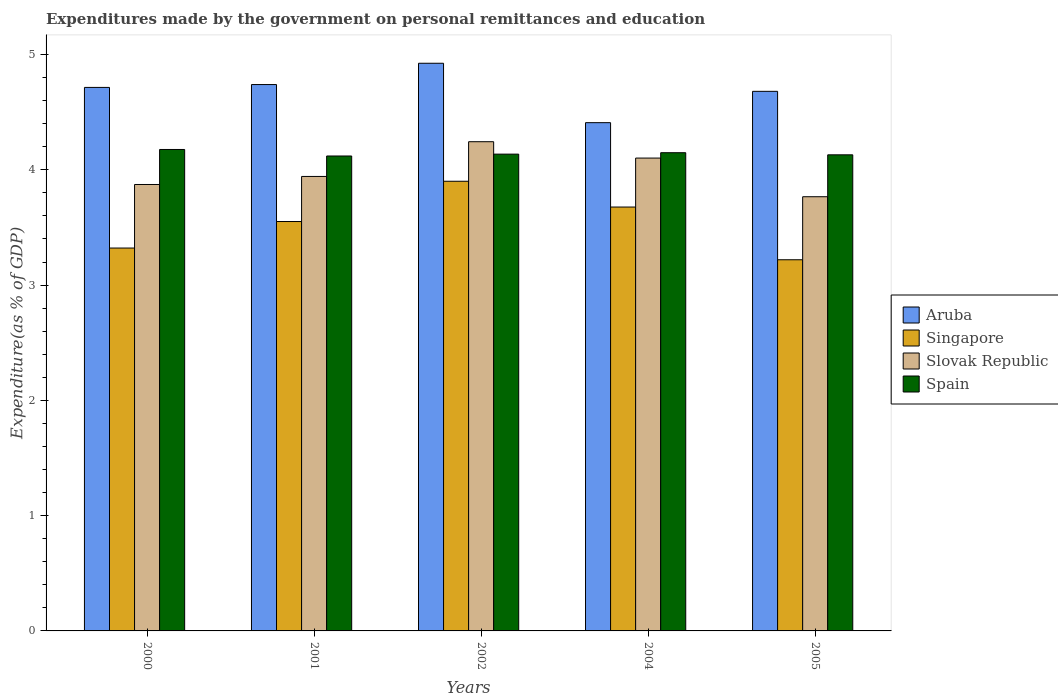Are the number of bars per tick equal to the number of legend labels?
Your answer should be compact. Yes. How many bars are there on the 3rd tick from the right?
Offer a terse response. 4. What is the expenditures made by the government on personal remittances and education in Singapore in 2001?
Make the answer very short. 3.55. Across all years, what is the maximum expenditures made by the government on personal remittances and education in Slovak Republic?
Make the answer very short. 4.24. Across all years, what is the minimum expenditures made by the government on personal remittances and education in Spain?
Keep it short and to the point. 4.12. In which year was the expenditures made by the government on personal remittances and education in Spain maximum?
Your response must be concise. 2000. What is the total expenditures made by the government on personal remittances and education in Singapore in the graph?
Offer a terse response. 17.67. What is the difference between the expenditures made by the government on personal remittances and education in Slovak Republic in 2000 and that in 2001?
Keep it short and to the point. -0.07. What is the difference between the expenditures made by the government on personal remittances and education in Aruba in 2005 and the expenditures made by the government on personal remittances and education in Slovak Republic in 2002?
Offer a terse response. 0.44. What is the average expenditures made by the government on personal remittances and education in Aruba per year?
Give a very brief answer. 4.69. In the year 2001, what is the difference between the expenditures made by the government on personal remittances and education in Slovak Republic and expenditures made by the government on personal remittances and education in Singapore?
Offer a terse response. 0.39. In how many years, is the expenditures made by the government on personal remittances and education in Singapore greater than 4.6 %?
Your response must be concise. 0. What is the ratio of the expenditures made by the government on personal remittances and education in Spain in 2000 to that in 2002?
Ensure brevity in your answer.  1.01. What is the difference between the highest and the second highest expenditures made by the government on personal remittances and education in Spain?
Your answer should be very brief. 0.03. What is the difference between the highest and the lowest expenditures made by the government on personal remittances and education in Spain?
Provide a succinct answer. 0.06. Is the sum of the expenditures made by the government on personal remittances and education in Spain in 2004 and 2005 greater than the maximum expenditures made by the government on personal remittances and education in Singapore across all years?
Ensure brevity in your answer.  Yes. What does the 1st bar from the left in 2001 represents?
Give a very brief answer. Aruba. What does the 3rd bar from the right in 2004 represents?
Offer a terse response. Singapore. Is it the case that in every year, the sum of the expenditures made by the government on personal remittances and education in Singapore and expenditures made by the government on personal remittances and education in Aruba is greater than the expenditures made by the government on personal remittances and education in Slovak Republic?
Your answer should be very brief. Yes. How many bars are there?
Your answer should be very brief. 20. Are the values on the major ticks of Y-axis written in scientific E-notation?
Ensure brevity in your answer.  No. Where does the legend appear in the graph?
Provide a short and direct response. Center right. What is the title of the graph?
Keep it short and to the point. Expenditures made by the government on personal remittances and education. What is the label or title of the Y-axis?
Your response must be concise. Expenditure(as % of GDP). What is the Expenditure(as % of GDP) of Aruba in 2000?
Ensure brevity in your answer.  4.71. What is the Expenditure(as % of GDP) in Singapore in 2000?
Make the answer very short. 3.32. What is the Expenditure(as % of GDP) in Slovak Republic in 2000?
Your response must be concise. 3.87. What is the Expenditure(as % of GDP) of Spain in 2000?
Your answer should be very brief. 4.18. What is the Expenditure(as % of GDP) in Aruba in 2001?
Your response must be concise. 4.74. What is the Expenditure(as % of GDP) in Singapore in 2001?
Provide a succinct answer. 3.55. What is the Expenditure(as % of GDP) in Slovak Republic in 2001?
Your response must be concise. 3.94. What is the Expenditure(as % of GDP) in Spain in 2001?
Your response must be concise. 4.12. What is the Expenditure(as % of GDP) in Aruba in 2002?
Your answer should be very brief. 4.92. What is the Expenditure(as % of GDP) of Singapore in 2002?
Give a very brief answer. 3.9. What is the Expenditure(as % of GDP) of Slovak Republic in 2002?
Offer a very short reply. 4.24. What is the Expenditure(as % of GDP) in Spain in 2002?
Make the answer very short. 4.14. What is the Expenditure(as % of GDP) of Aruba in 2004?
Provide a short and direct response. 4.41. What is the Expenditure(as % of GDP) of Singapore in 2004?
Your answer should be very brief. 3.68. What is the Expenditure(as % of GDP) in Slovak Republic in 2004?
Offer a very short reply. 4.1. What is the Expenditure(as % of GDP) in Spain in 2004?
Your answer should be compact. 4.15. What is the Expenditure(as % of GDP) of Aruba in 2005?
Offer a terse response. 4.68. What is the Expenditure(as % of GDP) of Singapore in 2005?
Give a very brief answer. 3.22. What is the Expenditure(as % of GDP) in Slovak Republic in 2005?
Offer a very short reply. 3.77. What is the Expenditure(as % of GDP) in Spain in 2005?
Make the answer very short. 4.13. Across all years, what is the maximum Expenditure(as % of GDP) in Aruba?
Offer a terse response. 4.92. Across all years, what is the maximum Expenditure(as % of GDP) of Singapore?
Your answer should be very brief. 3.9. Across all years, what is the maximum Expenditure(as % of GDP) in Slovak Republic?
Give a very brief answer. 4.24. Across all years, what is the maximum Expenditure(as % of GDP) of Spain?
Make the answer very short. 4.18. Across all years, what is the minimum Expenditure(as % of GDP) in Aruba?
Keep it short and to the point. 4.41. Across all years, what is the minimum Expenditure(as % of GDP) of Singapore?
Your answer should be compact. 3.22. Across all years, what is the minimum Expenditure(as % of GDP) of Slovak Republic?
Provide a short and direct response. 3.77. Across all years, what is the minimum Expenditure(as % of GDP) of Spain?
Give a very brief answer. 4.12. What is the total Expenditure(as % of GDP) in Aruba in the graph?
Offer a very short reply. 23.47. What is the total Expenditure(as % of GDP) of Singapore in the graph?
Your response must be concise. 17.67. What is the total Expenditure(as % of GDP) in Slovak Republic in the graph?
Offer a terse response. 19.93. What is the total Expenditure(as % of GDP) of Spain in the graph?
Give a very brief answer. 20.71. What is the difference between the Expenditure(as % of GDP) in Aruba in 2000 and that in 2001?
Your response must be concise. -0.02. What is the difference between the Expenditure(as % of GDP) of Singapore in 2000 and that in 2001?
Provide a succinct answer. -0.23. What is the difference between the Expenditure(as % of GDP) of Slovak Republic in 2000 and that in 2001?
Provide a succinct answer. -0.07. What is the difference between the Expenditure(as % of GDP) of Spain in 2000 and that in 2001?
Provide a succinct answer. 0.06. What is the difference between the Expenditure(as % of GDP) of Aruba in 2000 and that in 2002?
Offer a very short reply. -0.21. What is the difference between the Expenditure(as % of GDP) of Singapore in 2000 and that in 2002?
Your answer should be compact. -0.58. What is the difference between the Expenditure(as % of GDP) of Slovak Republic in 2000 and that in 2002?
Offer a terse response. -0.37. What is the difference between the Expenditure(as % of GDP) of Spain in 2000 and that in 2002?
Give a very brief answer. 0.04. What is the difference between the Expenditure(as % of GDP) of Aruba in 2000 and that in 2004?
Your response must be concise. 0.31. What is the difference between the Expenditure(as % of GDP) in Singapore in 2000 and that in 2004?
Keep it short and to the point. -0.36. What is the difference between the Expenditure(as % of GDP) in Slovak Republic in 2000 and that in 2004?
Provide a succinct answer. -0.23. What is the difference between the Expenditure(as % of GDP) in Spain in 2000 and that in 2004?
Provide a short and direct response. 0.03. What is the difference between the Expenditure(as % of GDP) in Aruba in 2000 and that in 2005?
Offer a very short reply. 0.03. What is the difference between the Expenditure(as % of GDP) of Singapore in 2000 and that in 2005?
Offer a terse response. 0.1. What is the difference between the Expenditure(as % of GDP) in Slovak Republic in 2000 and that in 2005?
Give a very brief answer. 0.11. What is the difference between the Expenditure(as % of GDP) in Spain in 2000 and that in 2005?
Offer a very short reply. 0.05. What is the difference between the Expenditure(as % of GDP) in Aruba in 2001 and that in 2002?
Your response must be concise. -0.18. What is the difference between the Expenditure(as % of GDP) of Singapore in 2001 and that in 2002?
Your response must be concise. -0.35. What is the difference between the Expenditure(as % of GDP) in Slovak Republic in 2001 and that in 2002?
Your response must be concise. -0.3. What is the difference between the Expenditure(as % of GDP) in Spain in 2001 and that in 2002?
Provide a succinct answer. -0.02. What is the difference between the Expenditure(as % of GDP) of Aruba in 2001 and that in 2004?
Your answer should be compact. 0.33. What is the difference between the Expenditure(as % of GDP) in Singapore in 2001 and that in 2004?
Your response must be concise. -0.13. What is the difference between the Expenditure(as % of GDP) in Slovak Republic in 2001 and that in 2004?
Give a very brief answer. -0.16. What is the difference between the Expenditure(as % of GDP) in Spain in 2001 and that in 2004?
Your response must be concise. -0.03. What is the difference between the Expenditure(as % of GDP) in Aruba in 2001 and that in 2005?
Ensure brevity in your answer.  0.06. What is the difference between the Expenditure(as % of GDP) in Singapore in 2001 and that in 2005?
Offer a very short reply. 0.33. What is the difference between the Expenditure(as % of GDP) of Slovak Republic in 2001 and that in 2005?
Your answer should be very brief. 0.18. What is the difference between the Expenditure(as % of GDP) of Spain in 2001 and that in 2005?
Give a very brief answer. -0.01. What is the difference between the Expenditure(as % of GDP) in Aruba in 2002 and that in 2004?
Offer a very short reply. 0.52. What is the difference between the Expenditure(as % of GDP) in Singapore in 2002 and that in 2004?
Give a very brief answer. 0.22. What is the difference between the Expenditure(as % of GDP) of Slovak Republic in 2002 and that in 2004?
Give a very brief answer. 0.14. What is the difference between the Expenditure(as % of GDP) of Spain in 2002 and that in 2004?
Ensure brevity in your answer.  -0.01. What is the difference between the Expenditure(as % of GDP) of Aruba in 2002 and that in 2005?
Give a very brief answer. 0.24. What is the difference between the Expenditure(as % of GDP) in Singapore in 2002 and that in 2005?
Make the answer very short. 0.68. What is the difference between the Expenditure(as % of GDP) in Slovak Republic in 2002 and that in 2005?
Provide a short and direct response. 0.48. What is the difference between the Expenditure(as % of GDP) of Spain in 2002 and that in 2005?
Your response must be concise. 0.01. What is the difference between the Expenditure(as % of GDP) in Aruba in 2004 and that in 2005?
Your answer should be very brief. -0.27. What is the difference between the Expenditure(as % of GDP) of Singapore in 2004 and that in 2005?
Offer a very short reply. 0.46. What is the difference between the Expenditure(as % of GDP) in Slovak Republic in 2004 and that in 2005?
Your answer should be compact. 0.34. What is the difference between the Expenditure(as % of GDP) in Spain in 2004 and that in 2005?
Your answer should be very brief. 0.02. What is the difference between the Expenditure(as % of GDP) of Aruba in 2000 and the Expenditure(as % of GDP) of Singapore in 2001?
Your answer should be very brief. 1.16. What is the difference between the Expenditure(as % of GDP) in Aruba in 2000 and the Expenditure(as % of GDP) in Slovak Republic in 2001?
Offer a very short reply. 0.77. What is the difference between the Expenditure(as % of GDP) in Aruba in 2000 and the Expenditure(as % of GDP) in Spain in 2001?
Give a very brief answer. 0.59. What is the difference between the Expenditure(as % of GDP) of Singapore in 2000 and the Expenditure(as % of GDP) of Slovak Republic in 2001?
Your answer should be very brief. -0.62. What is the difference between the Expenditure(as % of GDP) of Singapore in 2000 and the Expenditure(as % of GDP) of Spain in 2001?
Give a very brief answer. -0.8. What is the difference between the Expenditure(as % of GDP) in Slovak Republic in 2000 and the Expenditure(as % of GDP) in Spain in 2001?
Ensure brevity in your answer.  -0.25. What is the difference between the Expenditure(as % of GDP) of Aruba in 2000 and the Expenditure(as % of GDP) of Singapore in 2002?
Provide a succinct answer. 0.81. What is the difference between the Expenditure(as % of GDP) of Aruba in 2000 and the Expenditure(as % of GDP) of Slovak Republic in 2002?
Your response must be concise. 0.47. What is the difference between the Expenditure(as % of GDP) of Aruba in 2000 and the Expenditure(as % of GDP) of Spain in 2002?
Your answer should be very brief. 0.58. What is the difference between the Expenditure(as % of GDP) in Singapore in 2000 and the Expenditure(as % of GDP) in Slovak Republic in 2002?
Keep it short and to the point. -0.92. What is the difference between the Expenditure(as % of GDP) of Singapore in 2000 and the Expenditure(as % of GDP) of Spain in 2002?
Make the answer very short. -0.81. What is the difference between the Expenditure(as % of GDP) of Slovak Republic in 2000 and the Expenditure(as % of GDP) of Spain in 2002?
Your answer should be compact. -0.26. What is the difference between the Expenditure(as % of GDP) in Aruba in 2000 and the Expenditure(as % of GDP) in Singapore in 2004?
Keep it short and to the point. 1.04. What is the difference between the Expenditure(as % of GDP) of Aruba in 2000 and the Expenditure(as % of GDP) of Slovak Republic in 2004?
Offer a very short reply. 0.61. What is the difference between the Expenditure(as % of GDP) in Aruba in 2000 and the Expenditure(as % of GDP) in Spain in 2004?
Offer a terse response. 0.57. What is the difference between the Expenditure(as % of GDP) of Singapore in 2000 and the Expenditure(as % of GDP) of Slovak Republic in 2004?
Keep it short and to the point. -0.78. What is the difference between the Expenditure(as % of GDP) in Singapore in 2000 and the Expenditure(as % of GDP) in Spain in 2004?
Offer a terse response. -0.83. What is the difference between the Expenditure(as % of GDP) of Slovak Republic in 2000 and the Expenditure(as % of GDP) of Spain in 2004?
Keep it short and to the point. -0.28. What is the difference between the Expenditure(as % of GDP) in Aruba in 2000 and the Expenditure(as % of GDP) in Singapore in 2005?
Offer a terse response. 1.5. What is the difference between the Expenditure(as % of GDP) of Aruba in 2000 and the Expenditure(as % of GDP) of Slovak Republic in 2005?
Your answer should be very brief. 0.95. What is the difference between the Expenditure(as % of GDP) of Aruba in 2000 and the Expenditure(as % of GDP) of Spain in 2005?
Your response must be concise. 0.58. What is the difference between the Expenditure(as % of GDP) in Singapore in 2000 and the Expenditure(as % of GDP) in Slovak Republic in 2005?
Offer a very short reply. -0.45. What is the difference between the Expenditure(as % of GDP) of Singapore in 2000 and the Expenditure(as % of GDP) of Spain in 2005?
Your response must be concise. -0.81. What is the difference between the Expenditure(as % of GDP) in Slovak Republic in 2000 and the Expenditure(as % of GDP) in Spain in 2005?
Provide a succinct answer. -0.26. What is the difference between the Expenditure(as % of GDP) in Aruba in 2001 and the Expenditure(as % of GDP) in Singapore in 2002?
Make the answer very short. 0.84. What is the difference between the Expenditure(as % of GDP) in Aruba in 2001 and the Expenditure(as % of GDP) in Slovak Republic in 2002?
Your answer should be very brief. 0.5. What is the difference between the Expenditure(as % of GDP) of Aruba in 2001 and the Expenditure(as % of GDP) of Spain in 2002?
Ensure brevity in your answer.  0.6. What is the difference between the Expenditure(as % of GDP) in Singapore in 2001 and the Expenditure(as % of GDP) in Slovak Republic in 2002?
Your response must be concise. -0.69. What is the difference between the Expenditure(as % of GDP) in Singapore in 2001 and the Expenditure(as % of GDP) in Spain in 2002?
Offer a very short reply. -0.58. What is the difference between the Expenditure(as % of GDP) in Slovak Republic in 2001 and the Expenditure(as % of GDP) in Spain in 2002?
Keep it short and to the point. -0.19. What is the difference between the Expenditure(as % of GDP) of Aruba in 2001 and the Expenditure(as % of GDP) of Slovak Republic in 2004?
Your answer should be very brief. 0.64. What is the difference between the Expenditure(as % of GDP) of Aruba in 2001 and the Expenditure(as % of GDP) of Spain in 2004?
Provide a short and direct response. 0.59. What is the difference between the Expenditure(as % of GDP) in Singapore in 2001 and the Expenditure(as % of GDP) in Slovak Republic in 2004?
Give a very brief answer. -0.55. What is the difference between the Expenditure(as % of GDP) of Singapore in 2001 and the Expenditure(as % of GDP) of Spain in 2004?
Provide a succinct answer. -0.6. What is the difference between the Expenditure(as % of GDP) in Slovak Republic in 2001 and the Expenditure(as % of GDP) in Spain in 2004?
Make the answer very short. -0.21. What is the difference between the Expenditure(as % of GDP) in Aruba in 2001 and the Expenditure(as % of GDP) in Singapore in 2005?
Keep it short and to the point. 1.52. What is the difference between the Expenditure(as % of GDP) in Aruba in 2001 and the Expenditure(as % of GDP) in Spain in 2005?
Your answer should be very brief. 0.61. What is the difference between the Expenditure(as % of GDP) of Singapore in 2001 and the Expenditure(as % of GDP) of Slovak Republic in 2005?
Give a very brief answer. -0.22. What is the difference between the Expenditure(as % of GDP) of Singapore in 2001 and the Expenditure(as % of GDP) of Spain in 2005?
Ensure brevity in your answer.  -0.58. What is the difference between the Expenditure(as % of GDP) of Slovak Republic in 2001 and the Expenditure(as % of GDP) of Spain in 2005?
Provide a short and direct response. -0.19. What is the difference between the Expenditure(as % of GDP) in Aruba in 2002 and the Expenditure(as % of GDP) in Singapore in 2004?
Make the answer very short. 1.25. What is the difference between the Expenditure(as % of GDP) in Aruba in 2002 and the Expenditure(as % of GDP) in Slovak Republic in 2004?
Keep it short and to the point. 0.82. What is the difference between the Expenditure(as % of GDP) of Aruba in 2002 and the Expenditure(as % of GDP) of Spain in 2004?
Offer a terse response. 0.78. What is the difference between the Expenditure(as % of GDP) of Singapore in 2002 and the Expenditure(as % of GDP) of Slovak Republic in 2004?
Provide a short and direct response. -0.2. What is the difference between the Expenditure(as % of GDP) of Singapore in 2002 and the Expenditure(as % of GDP) of Spain in 2004?
Give a very brief answer. -0.25. What is the difference between the Expenditure(as % of GDP) in Slovak Republic in 2002 and the Expenditure(as % of GDP) in Spain in 2004?
Your response must be concise. 0.1. What is the difference between the Expenditure(as % of GDP) of Aruba in 2002 and the Expenditure(as % of GDP) of Singapore in 2005?
Give a very brief answer. 1.7. What is the difference between the Expenditure(as % of GDP) in Aruba in 2002 and the Expenditure(as % of GDP) in Slovak Republic in 2005?
Make the answer very short. 1.16. What is the difference between the Expenditure(as % of GDP) in Aruba in 2002 and the Expenditure(as % of GDP) in Spain in 2005?
Provide a short and direct response. 0.79. What is the difference between the Expenditure(as % of GDP) of Singapore in 2002 and the Expenditure(as % of GDP) of Slovak Republic in 2005?
Make the answer very short. 0.13. What is the difference between the Expenditure(as % of GDP) in Singapore in 2002 and the Expenditure(as % of GDP) in Spain in 2005?
Ensure brevity in your answer.  -0.23. What is the difference between the Expenditure(as % of GDP) of Slovak Republic in 2002 and the Expenditure(as % of GDP) of Spain in 2005?
Provide a succinct answer. 0.11. What is the difference between the Expenditure(as % of GDP) of Aruba in 2004 and the Expenditure(as % of GDP) of Singapore in 2005?
Offer a very short reply. 1.19. What is the difference between the Expenditure(as % of GDP) in Aruba in 2004 and the Expenditure(as % of GDP) in Slovak Republic in 2005?
Provide a short and direct response. 0.64. What is the difference between the Expenditure(as % of GDP) in Aruba in 2004 and the Expenditure(as % of GDP) in Spain in 2005?
Your answer should be very brief. 0.28. What is the difference between the Expenditure(as % of GDP) in Singapore in 2004 and the Expenditure(as % of GDP) in Slovak Republic in 2005?
Keep it short and to the point. -0.09. What is the difference between the Expenditure(as % of GDP) of Singapore in 2004 and the Expenditure(as % of GDP) of Spain in 2005?
Provide a short and direct response. -0.45. What is the difference between the Expenditure(as % of GDP) in Slovak Republic in 2004 and the Expenditure(as % of GDP) in Spain in 2005?
Offer a very short reply. -0.03. What is the average Expenditure(as % of GDP) of Aruba per year?
Give a very brief answer. 4.69. What is the average Expenditure(as % of GDP) in Singapore per year?
Offer a terse response. 3.53. What is the average Expenditure(as % of GDP) in Slovak Republic per year?
Your answer should be compact. 3.99. What is the average Expenditure(as % of GDP) in Spain per year?
Your answer should be very brief. 4.14. In the year 2000, what is the difference between the Expenditure(as % of GDP) of Aruba and Expenditure(as % of GDP) of Singapore?
Offer a terse response. 1.39. In the year 2000, what is the difference between the Expenditure(as % of GDP) in Aruba and Expenditure(as % of GDP) in Slovak Republic?
Keep it short and to the point. 0.84. In the year 2000, what is the difference between the Expenditure(as % of GDP) in Aruba and Expenditure(as % of GDP) in Spain?
Ensure brevity in your answer.  0.54. In the year 2000, what is the difference between the Expenditure(as % of GDP) in Singapore and Expenditure(as % of GDP) in Slovak Republic?
Your answer should be very brief. -0.55. In the year 2000, what is the difference between the Expenditure(as % of GDP) of Singapore and Expenditure(as % of GDP) of Spain?
Keep it short and to the point. -0.85. In the year 2000, what is the difference between the Expenditure(as % of GDP) in Slovak Republic and Expenditure(as % of GDP) in Spain?
Provide a short and direct response. -0.3. In the year 2001, what is the difference between the Expenditure(as % of GDP) of Aruba and Expenditure(as % of GDP) of Singapore?
Offer a very short reply. 1.19. In the year 2001, what is the difference between the Expenditure(as % of GDP) of Aruba and Expenditure(as % of GDP) of Slovak Republic?
Your response must be concise. 0.8. In the year 2001, what is the difference between the Expenditure(as % of GDP) of Aruba and Expenditure(as % of GDP) of Spain?
Ensure brevity in your answer.  0.62. In the year 2001, what is the difference between the Expenditure(as % of GDP) in Singapore and Expenditure(as % of GDP) in Slovak Republic?
Your response must be concise. -0.39. In the year 2001, what is the difference between the Expenditure(as % of GDP) of Singapore and Expenditure(as % of GDP) of Spain?
Make the answer very short. -0.57. In the year 2001, what is the difference between the Expenditure(as % of GDP) in Slovak Republic and Expenditure(as % of GDP) in Spain?
Offer a very short reply. -0.18. In the year 2002, what is the difference between the Expenditure(as % of GDP) in Aruba and Expenditure(as % of GDP) in Singapore?
Make the answer very short. 1.02. In the year 2002, what is the difference between the Expenditure(as % of GDP) of Aruba and Expenditure(as % of GDP) of Slovak Republic?
Provide a succinct answer. 0.68. In the year 2002, what is the difference between the Expenditure(as % of GDP) of Aruba and Expenditure(as % of GDP) of Spain?
Offer a terse response. 0.79. In the year 2002, what is the difference between the Expenditure(as % of GDP) of Singapore and Expenditure(as % of GDP) of Slovak Republic?
Offer a terse response. -0.34. In the year 2002, what is the difference between the Expenditure(as % of GDP) of Singapore and Expenditure(as % of GDP) of Spain?
Keep it short and to the point. -0.24. In the year 2002, what is the difference between the Expenditure(as % of GDP) in Slovak Republic and Expenditure(as % of GDP) in Spain?
Make the answer very short. 0.11. In the year 2004, what is the difference between the Expenditure(as % of GDP) in Aruba and Expenditure(as % of GDP) in Singapore?
Provide a succinct answer. 0.73. In the year 2004, what is the difference between the Expenditure(as % of GDP) of Aruba and Expenditure(as % of GDP) of Slovak Republic?
Your answer should be very brief. 0.31. In the year 2004, what is the difference between the Expenditure(as % of GDP) in Aruba and Expenditure(as % of GDP) in Spain?
Your answer should be very brief. 0.26. In the year 2004, what is the difference between the Expenditure(as % of GDP) of Singapore and Expenditure(as % of GDP) of Slovak Republic?
Give a very brief answer. -0.42. In the year 2004, what is the difference between the Expenditure(as % of GDP) of Singapore and Expenditure(as % of GDP) of Spain?
Make the answer very short. -0.47. In the year 2004, what is the difference between the Expenditure(as % of GDP) in Slovak Republic and Expenditure(as % of GDP) in Spain?
Make the answer very short. -0.05. In the year 2005, what is the difference between the Expenditure(as % of GDP) of Aruba and Expenditure(as % of GDP) of Singapore?
Offer a terse response. 1.46. In the year 2005, what is the difference between the Expenditure(as % of GDP) of Aruba and Expenditure(as % of GDP) of Slovak Republic?
Keep it short and to the point. 0.91. In the year 2005, what is the difference between the Expenditure(as % of GDP) in Aruba and Expenditure(as % of GDP) in Spain?
Provide a short and direct response. 0.55. In the year 2005, what is the difference between the Expenditure(as % of GDP) of Singapore and Expenditure(as % of GDP) of Slovak Republic?
Your answer should be compact. -0.55. In the year 2005, what is the difference between the Expenditure(as % of GDP) of Singapore and Expenditure(as % of GDP) of Spain?
Keep it short and to the point. -0.91. In the year 2005, what is the difference between the Expenditure(as % of GDP) in Slovak Republic and Expenditure(as % of GDP) in Spain?
Provide a succinct answer. -0.36. What is the ratio of the Expenditure(as % of GDP) in Singapore in 2000 to that in 2001?
Give a very brief answer. 0.94. What is the ratio of the Expenditure(as % of GDP) in Slovak Republic in 2000 to that in 2001?
Your answer should be very brief. 0.98. What is the ratio of the Expenditure(as % of GDP) of Spain in 2000 to that in 2001?
Your answer should be compact. 1.01. What is the ratio of the Expenditure(as % of GDP) in Aruba in 2000 to that in 2002?
Keep it short and to the point. 0.96. What is the ratio of the Expenditure(as % of GDP) in Singapore in 2000 to that in 2002?
Provide a short and direct response. 0.85. What is the ratio of the Expenditure(as % of GDP) of Slovak Republic in 2000 to that in 2002?
Your response must be concise. 0.91. What is the ratio of the Expenditure(as % of GDP) of Spain in 2000 to that in 2002?
Provide a succinct answer. 1.01. What is the ratio of the Expenditure(as % of GDP) of Aruba in 2000 to that in 2004?
Your answer should be compact. 1.07. What is the ratio of the Expenditure(as % of GDP) of Singapore in 2000 to that in 2004?
Provide a succinct answer. 0.9. What is the ratio of the Expenditure(as % of GDP) of Slovak Republic in 2000 to that in 2004?
Your response must be concise. 0.94. What is the ratio of the Expenditure(as % of GDP) of Spain in 2000 to that in 2004?
Give a very brief answer. 1.01. What is the ratio of the Expenditure(as % of GDP) of Aruba in 2000 to that in 2005?
Ensure brevity in your answer.  1.01. What is the ratio of the Expenditure(as % of GDP) of Singapore in 2000 to that in 2005?
Make the answer very short. 1.03. What is the ratio of the Expenditure(as % of GDP) of Slovak Republic in 2000 to that in 2005?
Your answer should be very brief. 1.03. What is the ratio of the Expenditure(as % of GDP) in Spain in 2000 to that in 2005?
Your answer should be very brief. 1.01. What is the ratio of the Expenditure(as % of GDP) in Aruba in 2001 to that in 2002?
Keep it short and to the point. 0.96. What is the ratio of the Expenditure(as % of GDP) of Singapore in 2001 to that in 2002?
Provide a short and direct response. 0.91. What is the ratio of the Expenditure(as % of GDP) of Slovak Republic in 2001 to that in 2002?
Offer a very short reply. 0.93. What is the ratio of the Expenditure(as % of GDP) in Spain in 2001 to that in 2002?
Your response must be concise. 1. What is the ratio of the Expenditure(as % of GDP) in Aruba in 2001 to that in 2004?
Give a very brief answer. 1.07. What is the ratio of the Expenditure(as % of GDP) of Singapore in 2001 to that in 2004?
Ensure brevity in your answer.  0.97. What is the ratio of the Expenditure(as % of GDP) in Slovak Republic in 2001 to that in 2004?
Your response must be concise. 0.96. What is the ratio of the Expenditure(as % of GDP) of Aruba in 2001 to that in 2005?
Offer a very short reply. 1.01. What is the ratio of the Expenditure(as % of GDP) of Singapore in 2001 to that in 2005?
Offer a terse response. 1.1. What is the ratio of the Expenditure(as % of GDP) of Slovak Republic in 2001 to that in 2005?
Provide a succinct answer. 1.05. What is the ratio of the Expenditure(as % of GDP) of Aruba in 2002 to that in 2004?
Make the answer very short. 1.12. What is the ratio of the Expenditure(as % of GDP) of Singapore in 2002 to that in 2004?
Give a very brief answer. 1.06. What is the ratio of the Expenditure(as % of GDP) of Slovak Republic in 2002 to that in 2004?
Give a very brief answer. 1.03. What is the ratio of the Expenditure(as % of GDP) in Aruba in 2002 to that in 2005?
Provide a short and direct response. 1.05. What is the ratio of the Expenditure(as % of GDP) of Singapore in 2002 to that in 2005?
Offer a very short reply. 1.21. What is the ratio of the Expenditure(as % of GDP) of Slovak Republic in 2002 to that in 2005?
Your answer should be compact. 1.13. What is the ratio of the Expenditure(as % of GDP) of Spain in 2002 to that in 2005?
Keep it short and to the point. 1. What is the ratio of the Expenditure(as % of GDP) of Aruba in 2004 to that in 2005?
Your response must be concise. 0.94. What is the ratio of the Expenditure(as % of GDP) in Singapore in 2004 to that in 2005?
Offer a terse response. 1.14. What is the ratio of the Expenditure(as % of GDP) of Slovak Republic in 2004 to that in 2005?
Make the answer very short. 1.09. What is the ratio of the Expenditure(as % of GDP) of Spain in 2004 to that in 2005?
Keep it short and to the point. 1. What is the difference between the highest and the second highest Expenditure(as % of GDP) of Aruba?
Give a very brief answer. 0.18. What is the difference between the highest and the second highest Expenditure(as % of GDP) in Singapore?
Your answer should be very brief. 0.22. What is the difference between the highest and the second highest Expenditure(as % of GDP) in Slovak Republic?
Offer a very short reply. 0.14. What is the difference between the highest and the second highest Expenditure(as % of GDP) of Spain?
Make the answer very short. 0.03. What is the difference between the highest and the lowest Expenditure(as % of GDP) of Aruba?
Your response must be concise. 0.52. What is the difference between the highest and the lowest Expenditure(as % of GDP) in Singapore?
Make the answer very short. 0.68. What is the difference between the highest and the lowest Expenditure(as % of GDP) of Slovak Republic?
Your answer should be compact. 0.48. What is the difference between the highest and the lowest Expenditure(as % of GDP) in Spain?
Ensure brevity in your answer.  0.06. 